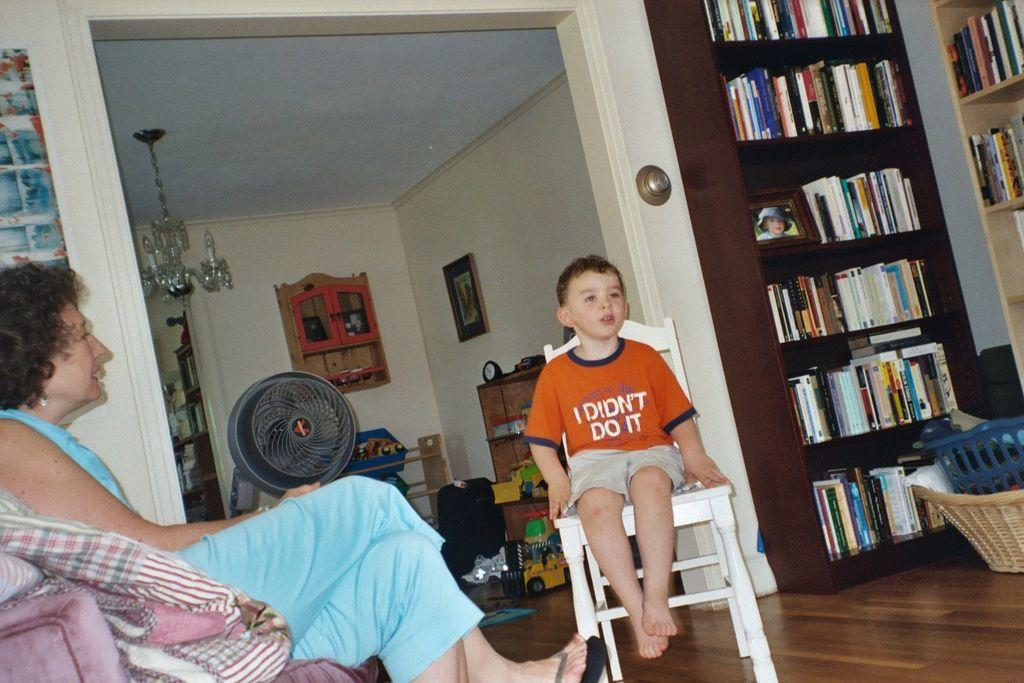<image>
Create a compact narrative representing the image presented. a little boy wearing an orange shirt that says 'i didn't do it' 